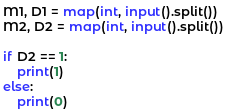<code> <loc_0><loc_0><loc_500><loc_500><_Python_>M1, D1 = map(int, input().split())
M2, D2 = map(int, input().split())

if D2 == 1:
    print(1)
else:
    print(0)
</code> 